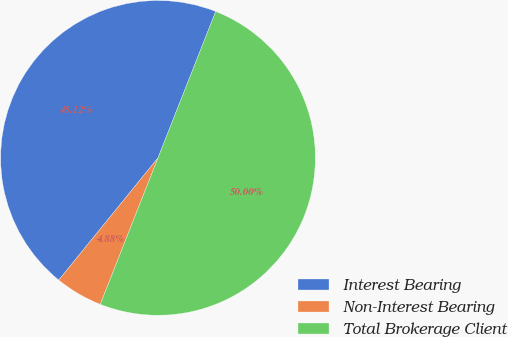<chart> <loc_0><loc_0><loc_500><loc_500><pie_chart><fcel>Interest Bearing<fcel>Non-Interest Bearing<fcel>Total Brokerage Client<nl><fcel>45.12%<fcel>4.88%<fcel>50.0%<nl></chart> 